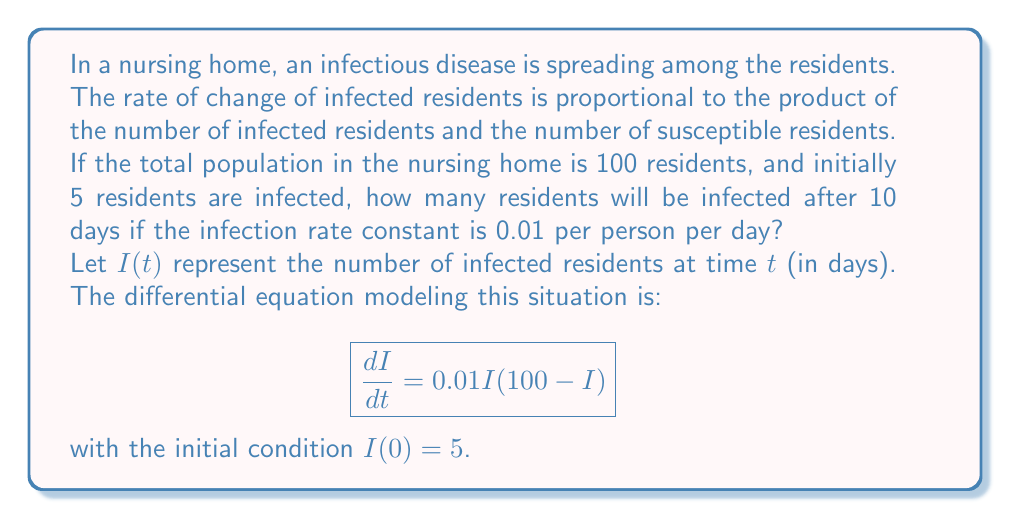Show me your answer to this math problem. To solve this problem, we need to use the logistic growth model, which is a first-order differential equation. Let's solve it step by step:

1) The differential equation is:
   $$\frac{dI}{dt} = 0.01I(100-I)$$

2) This is a separable equation. We can rewrite it as:
   $$\frac{dI}{I(100-I)} = 0.01dt$$

3) Integrate both sides:
   $$\int \frac{dI}{I(100-I)} = \int 0.01dt$$

4) The left side can be integrated using partial fractions:
   $$\frac{1}{100}\left(\frac{1}{I} + \frac{1}{100-I}\right)dI = 0.01dt$$

5) After integration:
   $$\frac{1}{100}[\ln|I| - \ln|100-I|] = 0.01t + C$$

6) Using the initial condition $I(0) = 5$, we can find $C$:
   $$\frac{1}{100}[\ln(5) - \ln(95)] = C$$

7) Substituting this back into the equation:
   $$\frac{1}{100}[\ln|I| - \ln|100-I|] = 0.01t + \frac{1}{100}[\ln(5) - \ln(95)]$$

8) Simplifying and solving for $I$:
   $$I = \frac{500}{1 + 19e^{-t}}$$

9) To find $I(10)$, we substitute $t = 10$:
   $$I(10) = \frac{500}{1 + 19e^{-10}} \approx 99.99$$

10) Since we're dealing with whole numbers of people, we round down to 99.
Answer: 99 residents 